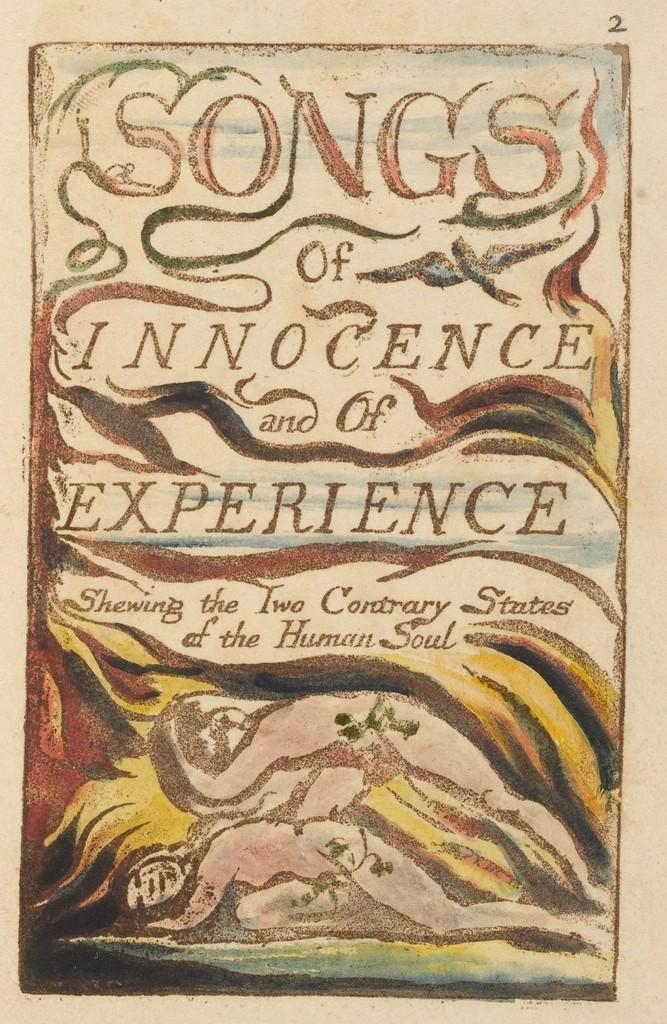<image>
Render a clear and concise summary of the photo. The book Songs of Innocence and of Experience sits on a table. 